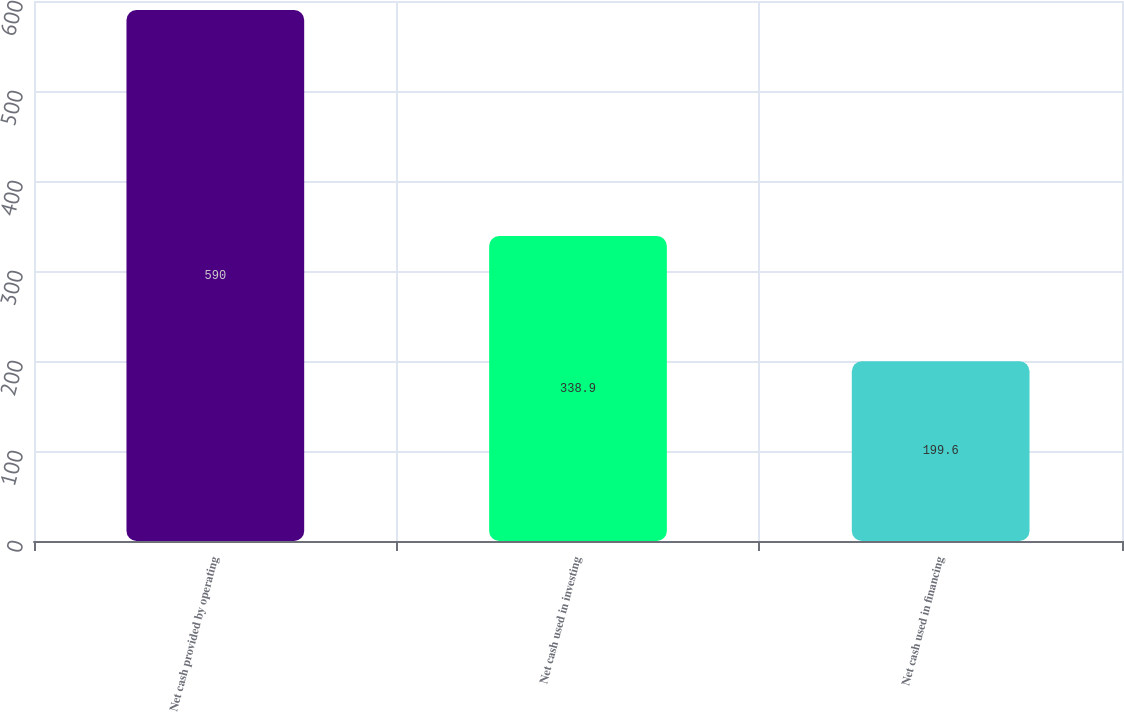<chart> <loc_0><loc_0><loc_500><loc_500><bar_chart><fcel>Net cash provided by operating<fcel>Net cash used in investing<fcel>Net cash used in financing<nl><fcel>590<fcel>338.9<fcel>199.6<nl></chart> 